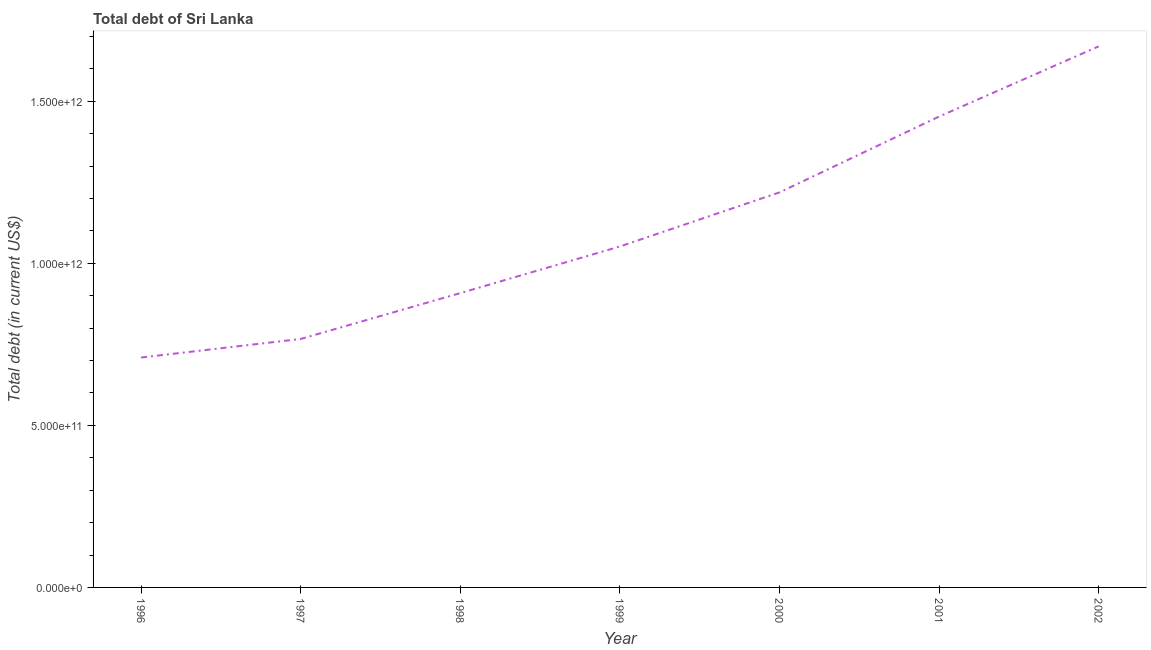What is the total debt in 1998?
Your response must be concise. 9.08e+11. Across all years, what is the maximum total debt?
Provide a succinct answer. 1.67e+12. Across all years, what is the minimum total debt?
Give a very brief answer. 7.09e+11. In which year was the total debt minimum?
Your answer should be compact. 1996. What is the sum of the total debt?
Give a very brief answer. 7.78e+12. What is the difference between the total debt in 2000 and 2002?
Make the answer very short. -4.51e+11. What is the average total debt per year?
Your answer should be very brief. 1.11e+12. What is the median total debt?
Make the answer very short. 1.05e+12. In how many years, is the total debt greater than 700000000000 US$?
Provide a succinct answer. 7. What is the ratio of the total debt in 1998 to that in 2000?
Your answer should be compact. 0.75. Is the total debt in 1996 less than that in 2001?
Your response must be concise. Yes. Is the difference between the total debt in 1996 and 2002 greater than the difference between any two years?
Offer a very short reply. Yes. What is the difference between the highest and the second highest total debt?
Your response must be concise. 2.17e+11. What is the difference between the highest and the lowest total debt?
Give a very brief answer. 9.60e+11. In how many years, is the total debt greater than the average total debt taken over all years?
Provide a succinct answer. 3. Does the total debt monotonically increase over the years?
Make the answer very short. Yes. How many years are there in the graph?
Offer a very short reply. 7. What is the difference between two consecutive major ticks on the Y-axis?
Make the answer very short. 5.00e+11. Are the values on the major ticks of Y-axis written in scientific E-notation?
Offer a very short reply. Yes. Does the graph contain any zero values?
Provide a succinct answer. No. What is the title of the graph?
Ensure brevity in your answer.  Total debt of Sri Lanka. What is the label or title of the Y-axis?
Make the answer very short. Total debt (in current US$). What is the Total debt (in current US$) of 1996?
Your answer should be very brief. 7.09e+11. What is the Total debt (in current US$) in 1997?
Offer a very short reply. 7.67e+11. What is the Total debt (in current US$) in 1998?
Ensure brevity in your answer.  9.08e+11. What is the Total debt (in current US$) of 1999?
Your response must be concise. 1.05e+12. What is the Total debt (in current US$) of 2000?
Ensure brevity in your answer.  1.22e+12. What is the Total debt (in current US$) in 2001?
Your answer should be compact. 1.45e+12. What is the Total debt (in current US$) in 2002?
Your response must be concise. 1.67e+12. What is the difference between the Total debt (in current US$) in 1996 and 1997?
Your answer should be compact. -5.73e+1. What is the difference between the Total debt (in current US$) in 1996 and 1998?
Provide a short and direct response. -1.99e+11. What is the difference between the Total debt (in current US$) in 1996 and 1999?
Your answer should be compact. -3.43e+11. What is the difference between the Total debt (in current US$) in 1996 and 2000?
Ensure brevity in your answer.  -5.09e+11. What is the difference between the Total debt (in current US$) in 1996 and 2001?
Your response must be concise. -7.43e+11. What is the difference between the Total debt (in current US$) in 1996 and 2002?
Your response must be concise. -9.60e+11. What is the difference between the Total debt (in current US$) in 1997 and 1998?
Your answer should be compact. -1.41e+11. What is the difference between the Total debt (in current US$) in 1997 and 1999?
Provide a short and direct response. -2.85e+11. What is the difference between the Total debt (in current US$) in 1997 and 2000?
Offer a very short reply. -4.52e+11. What is the difference between the Total debt (in current US$) in 1997 and 2001?
Provide a succinct answer. -6.86e+11. What is the difference between the Total debt (in current US$) in 1997 and 2002?
Offer a very short reply. -9.03e+11. What is the difference between the Total debt (in current US$) in 1998 and 1999?
Give a very brief answer. -1.44e+11. What is the difference between the Total debt (in current US$) in 1998 and 2000?
Provide a short and direct response. -3.11e+11. What is the difference between the Total debt (in current US$) in 1998 and 2001?
Keep it short and to the point. -5.45e+11. What is the difference between the Total debt (in current US$) in 1998 and 2002?
Provide a succinct answer. -7.61e+11. What is the difference between the Total debt (in current US$) in 1999 and 2000?
Provide a succinct answer. -1.67e+11. What is the difference between the Total debt (in current US$) in 1999 and 2001?
Your answer should be compact. -4.01e+11. What is the difference between the Total debt (in current US$) in 1999 and 2002?
Your response must be concise. -6.17e+11. What is the difference between the Total debt (in current US$) in 2000 and 2001?
Your response must be concise. -2.34e+11. What is the difference between the Total debt (in current US$) in 2000 and 2002?
Provide a succinct answer. -4.51e+11. What is the difference between the Total debt (in current US$) in 2001 and 2002?
Keep it short and to the point. -2.17e+11. What is the ratio of the Total debt (in current US$) in 1996 to that in 1997?
Make the answer very short. 0.93. What is the ratio of the Total debt (in current US$) in 1996 to that in 1998?
Keep it short and to the point. 0.78. What is the ratio of the Total debt (in current US$) in 1996 to that in 1999?
Provide a short and direct response. 0.67. What is the ratio of the Total debt (in current US$) in 1996 to that in 2000?
Your response must be concise. 0.58. What is the ratio of the Total debt (in current US$) in 1996 to that in 2001?
Your response must be concise. 0.49. What is the ratio of the Total debt (in current US$) in 1996 to that in 2002?
Your response must be concise. 0.42. What is the ratio of the Total debt (in current US$) in 1997 to that in 1998?
Your response must be concise. 0.84. What is the ratio of the Total debt (in current US$) in 1997 to that in 1999?
Your answer should be compact. 0.73. What is the ratio of the Total debt (in current US$) in 1997 to that in 2000?
Offer a very short reply. 0.63. What is the ratio of the Total debt (in current US$) in 1997 to that in 2001?
Offer a very short reply. 0.53. What is the ratio of the Total debt (in current US$) in 1997 to that in 2002?
Make the answer very short. 0.46. What is the ratio of the Total debt (in current US$) in 1998 to that in 1999?
Keep it short and to the point. 0.86. What is the ratio of the Total debt (in current US$) in 1998 to that in 2000?
Your response must be concise. 0.74. What is the ratio of the Total debt (in current US$) in 1998 to that in 2001?
Your response must be concise. 0.62. What is the ratio of the Total debt (in current US$) in 1998 to that in 2002?
Give a very brief answer. 0.54. What is the ratio of the Total debt (in current US$) in 1999 to that in 2000?
Your response must be concise. 0.86. What is the ratio of the Total debt (in current US$) in 1999 to that in 2001?
Your answer should be compact. 0.72. What is the ratio of the Total debt (in current US$) in 1999 to that in 2002?
Keep it short and to the point. 0.63. What is the ratio of the Total debt (in current US$) in 2000 to that in 2001?
Make the answer very short. 0.84. What is the ratio of the Total debt (in current US$) in 2000 to that in 2002?
Offer a very short reply. 0.73. What is the ratio of the Total debt (in current US$) in 2001 to that in 2002?
Ensure brevity in your answer.  0.87. 